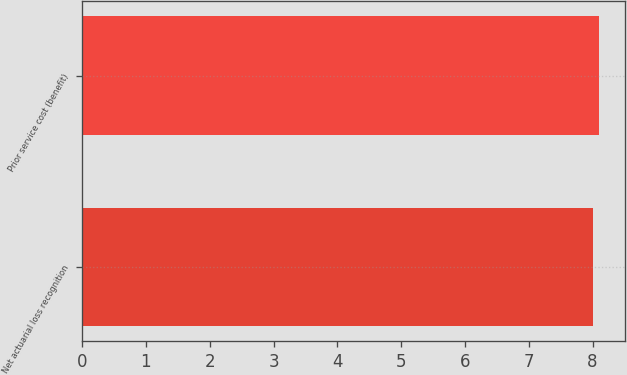Convert chart to OTSL. <chart><loc_0><loc_0><loc_500><loc_500><bar_chart><fcel>Net actuarial loss recognition<fcel>Prior service cost (benefit)<nl><fcel>8<fcel>8.1<nl></chart> 